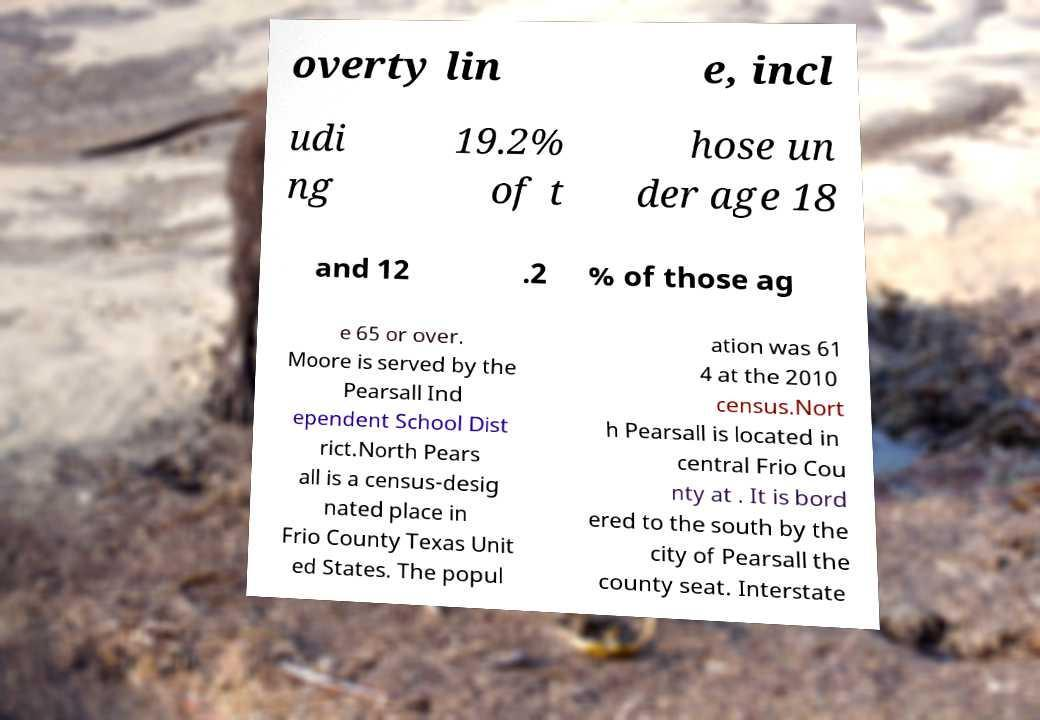Could you assist in decoding the text presented in this image and type it out clearly? overty lin e, incl udi ng 19.2% of t hose un der age 18 and 12 .2 % of those ag e 65 or over. Moore is served by the Pearsall Ind ependent School Dist rict.North Pears all is a census-desig nated place in Frio County Texas Unit ed States. The popul ation was 61 4 at the 2010 census.Nort h Pearsall is located in central Frio Cou nty at . It is bord ered to the south by the city of Pearsall the county seat. Interstate 